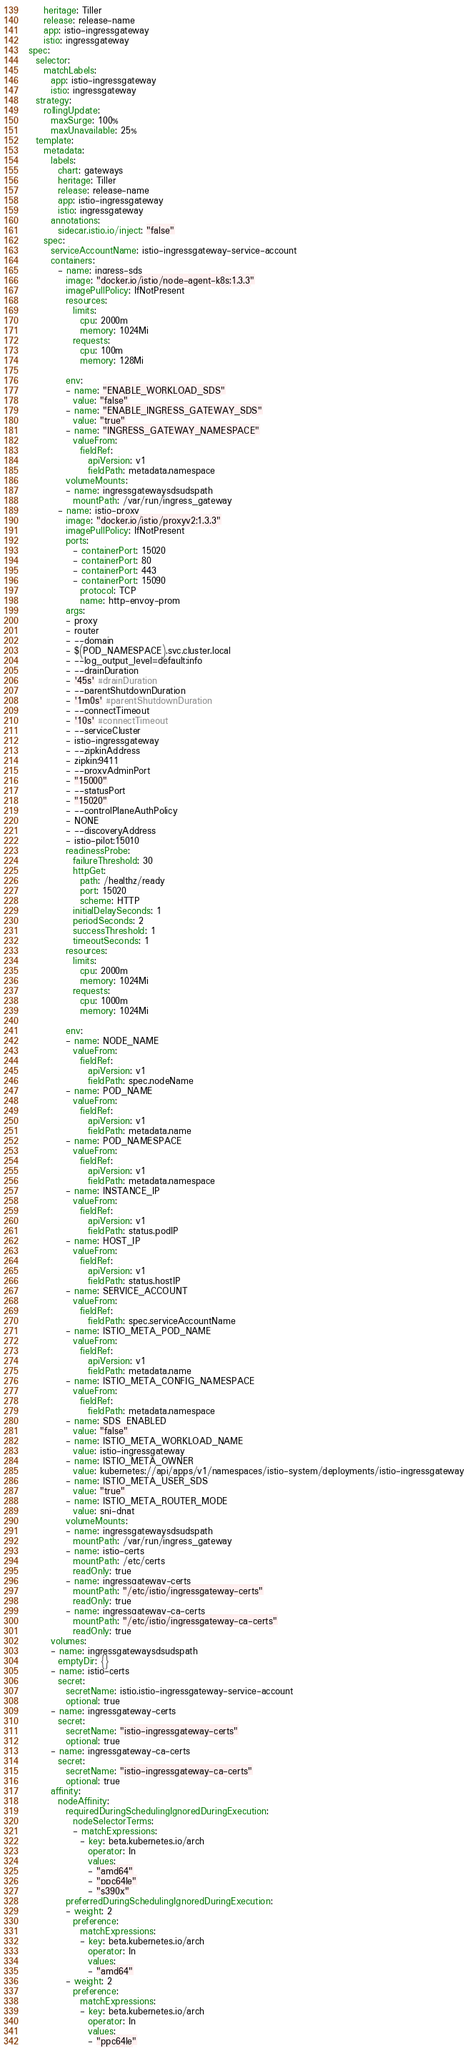<code> <loc_0><loc_0><loc_500><loc_500><_YAML_>    heritage: Tiller
    release: release-name
    app: istio-ingressgateway
    istio: ingressgateway
spec:
  selector:
    matchLabels:
      app: istio-ingressgateway
      istio: ingressgateway
  strategy:
    rollingUpdate:
      maxSurge: 100%
      maxUnavailable: 25%
  template:
    metadata:
      labels:
        chart: gateways
        heritage: Tiller
        release: release-name
        app: istio-ingressgateway
        istio: ingressgateway
      annotations:
        sidecar.istio.io/inject: "false"
    spec:
      serviceAccountName: istio-ingressgateway-service-account
      containers:
        - name: ingress-sds
          image: "docker.io/istio/node-agent-k8s:1.3.3"
          imagePullPolicy: IfNotPresent
          resources:
            limits:
              cpu: 2000m
              memory: 1024Mi
            requests:
              cpu: 100m
              memory: 128Mi

          env:
          - name: "ENABLE_WORKLOAD_SDS"
            value: "false"
          - name: "ENABLE_INGRESS_GATEWAY_SDS"
            value: "true"
          - name: "INGRESS_GATEWAY_NAMESPACE"
            valueFrom:
              fieldRef:
                apiVersion: v1
                fieldPath: metadata.namespace
          volumeMounts:
          - name: ingressgatewaysdsudspath
            mountPath: /var/run/ingress_gateway
        - name: istio-proxy
          image: "docker.io/istio/proxyv2:1.3.3"
          imagePullPolicy: IfNotPresent
          ports:
            - containerPort: 15020
            - containerPort: 80
            - containerPort: 443
            - containerPort: 15090
              protocol: TCP
              name: http-envoy-prom
          args:
          - proxy
          - router
          - --domain
          - $(POD_NAMESPACE).svc.cluster.local
          - --log_output_level=default:info
          - --drainDuration
          - '45s' #drainDuration
          - --parentShutdownDuration
          - '1m0s' #parentShutdownDuration
          - --connectTimeout
          - '10s' #connectTimeout
          - --serviceCluster
          - istio-ingressgateway
          - --zipkinAddress
          - zipkin:9411
          - --proxyAdminPort
          - "15000"
          - --statusPort
          - "15020"
          - --controlPlaneAuthPolicy
          - NONE
          - --discoveryAddress
          - istio-pilot:15010
          readinessProbe:
            failureThreshold: 30
            httpGet:
              path: /healthz/ready
              port: 15020
              scheme: HTTP
            initialDelaySeconds: 1
            periodSeconds: 2
            successThreshold: 1
            timeoutSeconds: 1
          resources:
            limits:
              cpu: 2000m
              memory: 1024Mi
            requests:
              cpu: 1000m
              memory: 1024Mi

          env:
          - name: NODE_NAME
            valueFrom:
              fieldRef:
                apiVersion: v1
                fieldPath: spec.nodeName
          - name: POD_NAME
            valueFrom:
              fieldRef:
                apiVersion: v1
                fieldPath: metadata.name
          - name: POD_NAMESPACE
            valueFrom:
              fieldRef:
                apiVersion: v1
                fieldPath: metadata.namespace
          - name: INSTANCE_IP
            valueFrom:
              fieldRef:
                apiVersion: v1
                fieldPath: status.podIP
          - name: HOST_IP
            valueFrom:
              fieldRef:
                apiVersion: v1
                fieldPath: status.hostIP
          - name: SERVICE_ACCOUNT
            valueFrom:
              fieldRef:
                fieldPath: spec.serviceAccountName
          - name: ISTIO_META_POD_NAME
            valueFrom:
              fieldRef:
                apiVersion: v1
                fieldPath: metadata.name
          - name: ISTIO_META_CONFIG_NAMESPACE
            valueFrom:
              fieldRef:
                fieldPath: metadata.namespace
          - name: SDS_ENABLED
            value: "false"
          - name: ISTIO_META_WORKLOAD_NAME
            value: istio-ingressgateway
          - name: ISTIO_META_OWNER
            value: kubernetes://api/apps/v1/namespaces/istio-system/deployments/istio-ingressgateway
          - name: ISTIO_META_USER_SDS
            value: "true"
          - name: ISTIO_META_ROUTER_MODE
            value: sni-dnat
          volumeMounts:
          - name: ingressgatewaysdsudspath
            mountPath: /var/run/ingress_gateway
          - name: istio-certs
            mountPath: /etc/certs
            readOnly: true
          - name: ingressgateway-certs
            mountPath: "/etc/istio/ingressgateway-certs"
            readOnly: true
          - name: ingressgateway-ca-certs
            mountPath: "/etc/istio/ingressgateway-ca-certs"
            readOnly: true
      volumes:
      - name: ingressgatewaysdsudspath
        emptyDir: {}
      - name: istio-certs
        secret:
          secretName: istio.istio-ingressgateway-service-account
          optional: true
      - name: ingressgateway-certs
        secret:
          secretName: "istio-ingressgateway-certs"
          optional: true
      - name: ingressgateway-ca-certs
        secret:
          secretName: "istio-ingressgateway-ca-certs"
          optional: true
      affinity:
        nodeAffinity:
          requiredDuringSchedulingIgnoredDuringExecution:
            nodeSelectorTerms:
            - matchExpressions:
              - key: beta.kubernetes.io/arch
                operator: In
                values:
                - "amd64"
                - "ppc64le"
                - "s390x"
          preferredDuringSchedulingIgnoredDuringExecution:
          - weight: 2
            preference:
              matchExpressions:
              - key: beta.kubernetes.io/arch
                operator: In
                values:
                - "amd64"
          - weight: 2
            preference:
              matchExpressions:
              - key: beta.kubernetes.io/arch
                operator: In
                values:
                - "ppc64le"</code> 